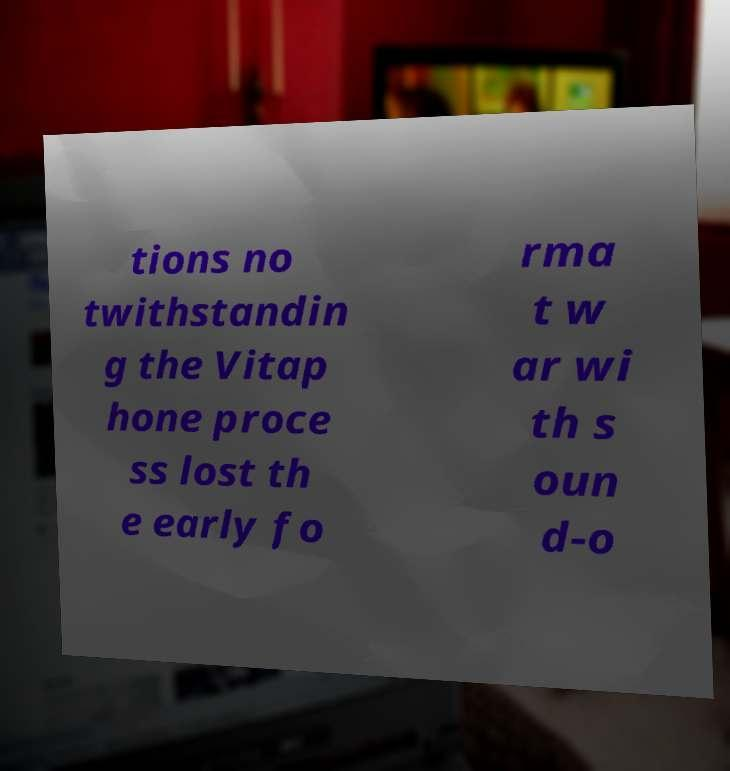I need the written content from this picture converted into text. Can you do that? tions no twithstandin g the Vitap hone proce ss lost th e early fo rma t w ar wi th s oun d-o 